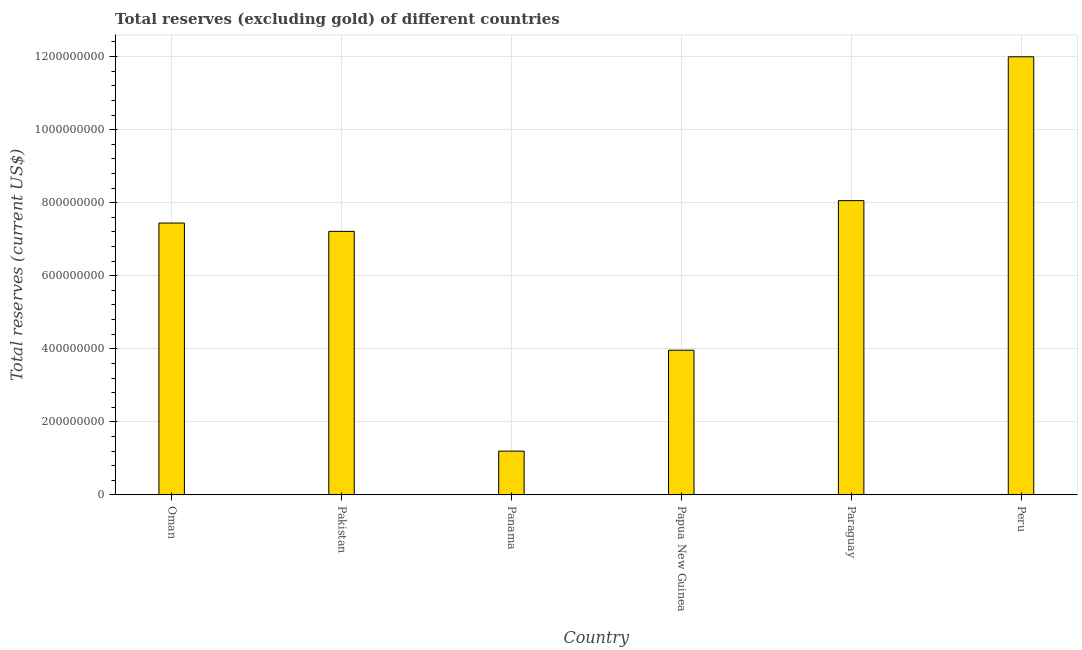Does the graph contain any zero values?
Give a very brief answer. No. What is the title of the graph?
Offer a terse response. Total reserves (excluding gold) of different countries. What is the label or title of the X-axis?
Make the answer very short. Country. What is the label or title of the Y-axis?
Your answer should be compact. Total reserves (current US$). What is the total reserves (excluding gold) in Paraguay?
Your answer should be very brief. 8.06e+08. Across all countries, what is the maximum total reserves (excluding gold)?
Keep it short and to the point. 1.20e+09. Across all countries, what is the minimum total reserves (excluding gold)?
Your answer should be compact. 1.20e+08. In which country was the total reserves (excluding gold) maximum?
Provide a short and direct response. Peru. In which country was the total reserves (excluding gold) minimum?
Provide a short and direct response. Panama. What is the sum of the total reserves (excluding gold)?
Keep it short and to the point. 3.99e+09. What is the difference between the total reserves (excluding gold) in Papua New Guinea and Paraguay?
Make the answer very short. -4.10e+08. What is the average total reserves (excluding gold) per country?
Your response must be concise. 6.65e+08. What is the median total reserves (excluding gold)?
Keep it short and to the point. 7.33e+08. Is the difference between the total reserves (excluding gold) in Pakistan and Papua New Guinea greater than the difference between any two countries?
Give a very brief answer. No. What is the difference between the highest and the second highest total reserves (excluding gold)?
Your answer should be very brief. 3.94e+08. What is the difference between the highest and the lowest total reserves (excluding gold)?
Your answer should be compact. 1.08e+09. How many bars are there?
Provide a succinct answer. 6. What is the Total reserves (current US$) of Oman?
Offer a terse response. 7.44e+08. What is the Total reserves (current US$) in Pakistan?
Make the answer very short. 7.21e+08. What is the Total reserves (current US$) in Panama?
Offer a very short reply. 1.20e+08. What is the Total reserves (current US$) in Papua New Guinea?
Offer a terse response. 3.96e+08. What is the Total reserves (current US$) of Paraguay?
Offer a terse response. 8.06e+08. What is the Total reserves (current US$) of Peru?
Your answer should be compact. 1.20e+09. What is the difference between the Total reserves (current US$) in Oman and Pakistan?
Ensure brevity in your answer.  2.28e+07. What is the difference between the Total reserves (current US$) in Oman and Panama?
Make the answer very short. 6.24e+08. What is the difference between the Total reserves (current US$) in Oman and Papua New Guinea?
Keep it short and to the point. 3.48e+08. What is the difference between the Total reserves (current US$) in Oman and Paraguay?
Provide a short and direct response. -6.14e+07. What is the difference between the Total reserves (current US$) in Oman and Peru?
Provide a succinct answer. -4.55e+08. What is the difference between the Total reserves (current US$) in Pakistan and Panama?
Offer a terse response. 6.02e+08. What is the difference between the Total reserves (current US$) in Pakistan and Papua New Guinea?
Your answer should be very brief. 3.25e+08. What is the difference between the Total reserves (current US$) in Pakistan and Paraguay?
Ensure brevity in your answer.  -8.42e+07. What is the difference between the Total reserves (current US$) in Pakistan and Peru?
Give a very brief answer. -4.78e+08. What is the difference between the Total reserves (current US$) in Panama and Papua New Guinea?
Provide a short and direct response. -2.76e+08. What is the difference between the Total reserves (current US$) in Panama and Paraguay?
Offer a very short reply. -6.86e+08. What is the difference between the Total reserves (current US$) in Panama and Peru?
Keep it short and to the point. -1.08e+09. What is the difference between the Total reserves (current US$) in Papua New Guinea and Paraguay?
Keep it short and to the point. -4.10e+08. What is the difference between the Total reserves (current US$) in Papua New Guinea and Peru?
Keep it short and to the point. -8.03e+08. What is the difference between the Total reserves (current US$) in Paraguay and Peru?
Keep it short and to the point. -3.94e+08. What is the ratio of the Total reserves (current US$) in Oman to that in Pakistan?
Offer a very short reply. 1.03. What is the ratio of the Total reserves (current US$) in Oman to that in Panama?
Your response must be concise. 6.21. What is the ratio of the Total reserves (current US$) in Oman to that in Papua New Guinea?
Offer a very short reply. 1.88. What is the ratio of the Total reserves (current US$) in Oman to that in Paraguay?
Your answer should be compact. 0.92. What is the ratio of the Total reserves (current US$) in Oman to that in Peru?
Offer a terse response. 0.62. What is the ratio of the Total reserves (current US$) in Pakistan to that in Panama?
Provide a succinct answer. 6.01. What is the ratio of the Total reserves (current US$) in Pakistan to that in Papua New Guinea?
Offer a terse response. 1.82. What is the ratio of the Total reserves (current US$) in Pakistan to that in Paraguay?
Offer a very short reply. 0.9. What is the ratio of the Total reserves (current US$) in Pakistan to that in Peru?
Make the answer very short. 0.6. What is the ratio of the Total reserves (current US$) in Panama to that in Papua New Guinea?
Offer a terse response. 0.3. What is the ratio of the Total reserves (current US$) in Panama to that in Paraguay?
Give a very brief answer. 0.15. What is the ratio of the Total reserves (current US$) in Papua New Guinea to that in Paraguay?
Your answer should be very brief. 0.49. What is the ratio of the Total reserves (current US$) in Papua New Guinea to that in Peru?
Your answer should be very brief. 0.33. What is the ratio of the Total reserves (current US$) in Paraguay to that in Peru?
Offer a terse response. 0.67. 